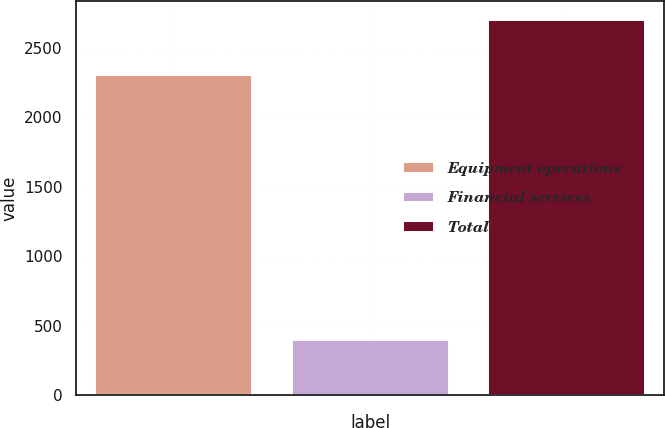<chart> <loc_0><loc_0><loc_500><loc_500><bar_chart><fcel>Equipment operations<fcel>Financial services<fcel>Total<nl><fcel>2302<fcel>400<fcel>2702<nl></chart> 